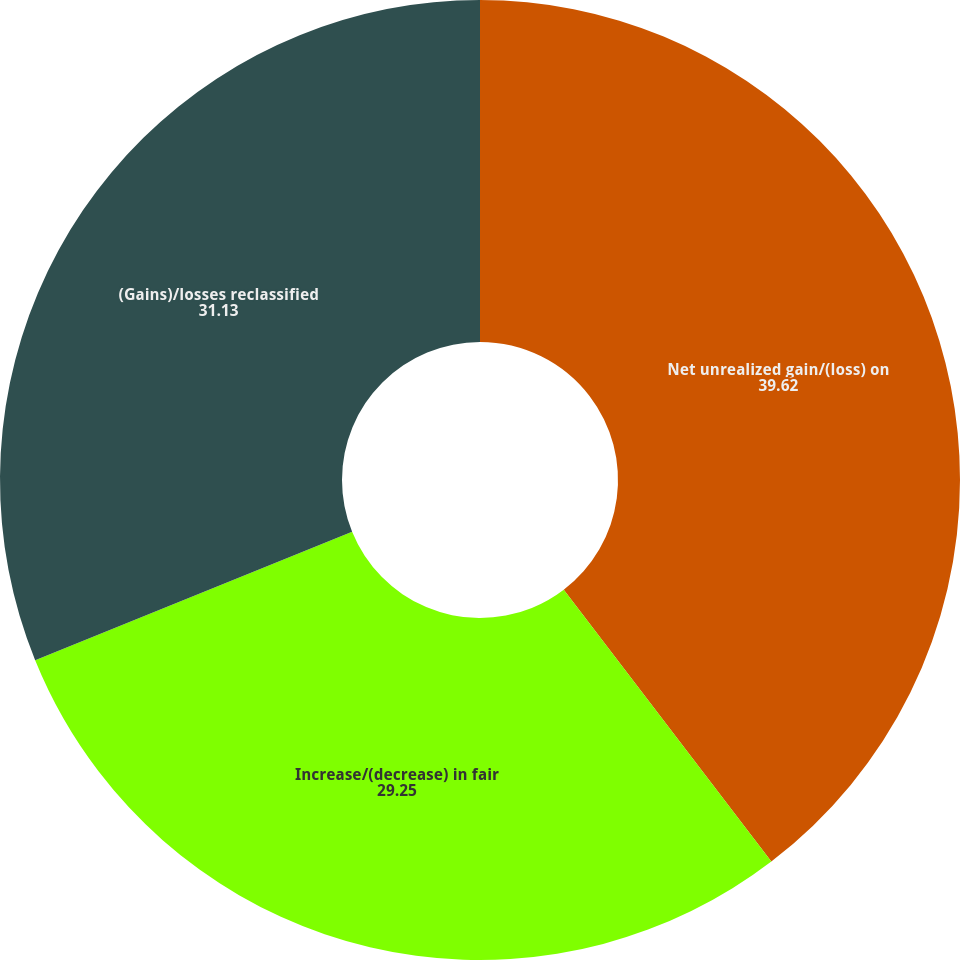<chart> <loc_0><loc_0><loc_500><loc_500><pie_chart><fcel>Net unrealized gain/(loss) on<fcel>Increase/(decrease) in fair<fcel>(Gains)/losses reclassified<nl><fcel>39.62%<fcel>29.25%<fcel>31.13%<nl></chart> 